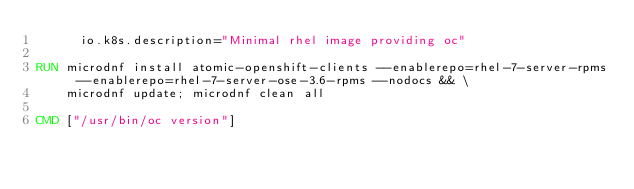<code> <loc_0><loc_0><loc_500><loc_500><_Dockerfile_>      io.k8s.description="Minimal rhel image providing oc"

RUN microdnf install atomic-openshift-clients --enablerepo=rhel-7-server-rpms --enablerepo=rhel-7-server-ose-3.6-rpms --nodocs && \
    microdnf update; microdnf clean all

CMD ["/usr/bin/oc version"]
</code> 